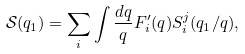<formula> <loc_0><loc_0><loc_500><loc_500>\mathcal { S } ( q _ { 1 } ) = \sum _ { i } \int \frac { d q } { q } F ^ { \prime } _ { i } ( q ) S ^ { j } _ { i } ( q _ { 1 } / q ) ,</formula> 